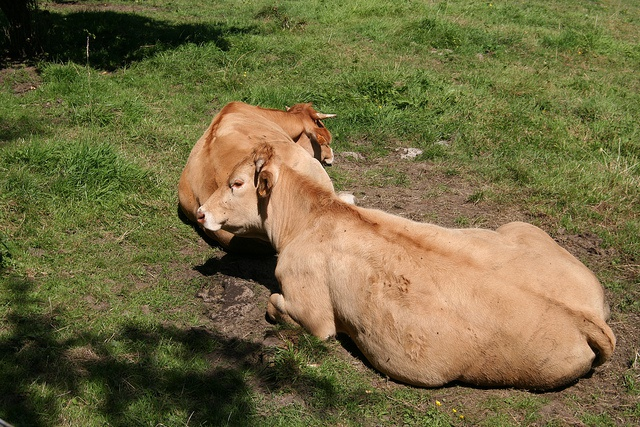Describe the objects in this image and their specific colors. I can see cow in black, tan, and gray tones and cow in black, tan, and brown tones in this image. 